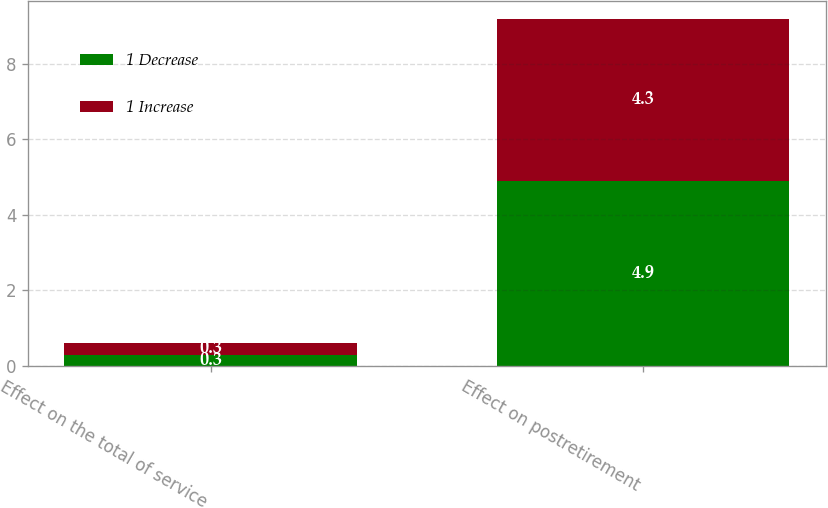Convert chart. <chart><loc_0><loc_0><loc_500><loc_500><stacked_bar_chart><ecel><fcel>Effect on the total of service<fcel>Effect on postretirement<nl><fcel>1 Decrease<fcel>0.3<fcel>4.9<nl><fcel>1 Increase<fcel>0.3<fcel>4.3<nl></chart> 